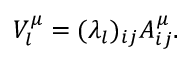<formula> <loc_0><loc_0><loc_500><loc_500>V _ { l } ^ { \mu } = ( \lambda _ { l } ) _ { i j } A _ { i j } ^ { \mu } .</formula> 